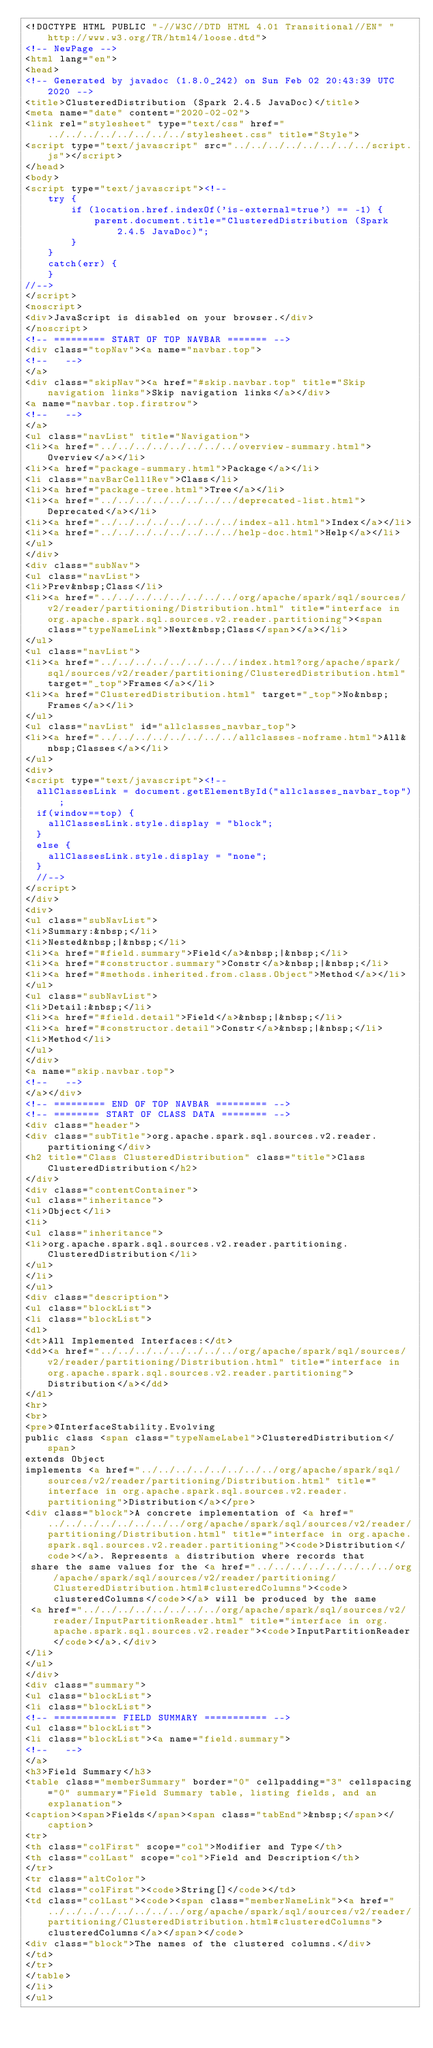<code> <loc_0><loc_0><loc_500><loc_500><_HTML_><!DOCTYPE HTML PUBLIC "-//W3C//DTD HTML 4.01 Transitional//EN" "http://www.w3.org/TR/html4/loose.dtd">
<!-- NewPage -->
<html lang="en">
<head>
<!-- Generated by javadoc (1.8.0_242) on Sun Feb 02 20:43:39 UTC 2020 -->
<title>ClusteredDistribution (Spark 2.4.5 JavaDoc)</title>
<meta name="date" content="2020-02-02">
<link rel="stylesheet" type="text/css" href="../../../../../../../../stylesheet.css" title="Style">
<script type="text/javascript" src="../../../../../../../../script.js"></script>
</head>
<body>
<script type="text/javascript"><!--
    try {
        if (location.href.indexOf('is-external=true') == -1) {
            parent.document.title="ClusteredDistribution (Spark 2.4.5 JavaDoc)";
        }
    }
    catch(err) {
    }
//-->
</script>
<noscript>
<div>JavaScript is disabled on your browser.</div>
</noscript>
<!-- ========= START OF TOP NAVBAR ======= -->
<div class="topNav"><a name="navbar.top">
<!--   -->
</a>
<div class="skipNav"><a href="#skip.navbar.top" title="Skip navigation links">Skip navigation links</a></div>
<a name="navbar.top.firstrow">
<!--   -->
</a>
<ul class="navList" title="Navigation">
<li><a href="../../../../../../../../overview-summary.html">Overview</a></li>
<li><a href="package-summary.html">Package</a></li>
<li class="navBarCell1Rev">Class</li>
<li><a href="package-tree.html">Tree</a></li>
<li><a href="../../../../../../../../deprecated-list.html">Deprecated</a></li>
<li><a href="../../../../../../../../index-all.html">Index</a></li>
<li><a href="../../../../../../../../help-doc.html">Help</a></li>
</ul>
</div>
<div class="subNav">
<ul class="navList">
<li>Prev&nbsp;Class</li>
<li><a href="../../../../../../../../org/apache/spark/sql/sources/v2/reader/partitioning/Distribution.html" title="interface in org.apache.spark.sql.sources.v2.reader.partitioning"><span class="typeNameLink">Next&nbsp;Class</span></a></li>
</ul>
<ul class="navList">
<li><a href="../../../../../../../../index.html?org/apache/spark/sql/sources/v2/reader/partitioning/ClusteredDistribution.html" target="_top">Frames</a></li>
<li><a href="ClusteredDistribution.html" target="_top">No&nbsp;Frames</a></li>
</ul>
<ul class="navList" id="allclasses_navbar_top">
<li><a href="../../../../../../../../allclasses-noframe.html">All&nbsp;Classes</a></li>
</ul>
<div>
<script type="text/javascript"><!--
  allClassesLink = document.getElementById("allclasses_navbar_top");
  if(window==top) {
    allClassesLink.style.display = "block";
  }
  else {
    allClassesLink.style.display = "none";
  }
  //-->
</script>
</div>
<div>
<ul class="subNavList">
<li>Summary:&nbsp;</li>
<li>Nested&nbsp;|&nbsp;</li>
<li><a href="#field.summary">Field</a>&nbsp;|&nbsp;</li>
<li><a href="#constructor.summary">Constr</a>&nbsp;|&nbsp;</li>
<li><a href="#methods.inherited.from.class.Object">Method</a></li>
</ul>
<ul class="subNavList">
<li>Detail:&nbsp;</li>
<li><a href="#field.detail">Field</a>&nbsp;|&nbsp;</li>
<li><a href="#constructor.detail">Constr</a>&nbsp;|&nbsp;</li>
<li>Method</li>
</ul>
</div>
<a name="skip.navbar.top">
<!--   -->
</a></div>
<!-- ========= END OF TOP NAVBAR ========= -->
<!-- ======== START OF CLASS DATA ======== -->
<div class="header">
<div class="subTitle">org.apache.spark.sql.sources.v2.reader.partitioning</div>
<h2 title="Class ClusteredDistribution" class="title">Class ClusteredDistribution</h2>
</div>
<div class="contentContainer">
<ul class="inheritance">
<li>Object</li>
<li>
<ul class="inheritance">
<li>org.apache.spark.sql.sources.v2.reader.partitioning.ClusteredDistribution</li>
</ul>
</li>
</ul>
<div class="description">
<ul class="blockList">
<li class="blockList">
<dl>
<dt>All Implemented Interfaces:</dt>
<dd><a href="../../../../../../../../org/apache/spark/sql/sources/v2/reader/partitioning/Distribution.html" title="interface in org.apache.spark.sql.sources.v2.reader.partitioning">Distribution</a></dd>
</dl>
<hr>
<br>
<pre>@InterfaceStability.Evolving
public class <span class="typeNameLabel">ClusteredDistribution</span>
extends Object
implements <a href="../../../../../../../../org/apache/spark/sql/sources/v2/reader/partitioning/Distribution.html" title="interface in org.apache.spark.sql.sources.v2.reader.partitioning">Distribution</a></pre>
<div class="block">A concrete implementation of <a href="../../../../../../../../org/apache/spark/sql/sources/v2/reader/partitioning/Distribution.html" title="interface in org.apache.spark.sql.sources.v2.reader.partitioning"><code>Distribution</code></a>. Represents a distribution where records that
 share the same values for the <a href="../../../../../../../../org/apache/spark/sql/sources/v2/reader/partitioning/ClusteredDistribution.html#clusteredColumns"><code>clusteredColumns</code></a> will be produced by the same
 <a href="../../../../../../../../org/apache/spark/sql/sources/v2/reader/InputPartitionReader.html" title="interface in org.apache.spark.sql.sources.v2.reader"><code>InputPartitionReader</code></a>.</div>
</li>
</ul>
</div>
<div class="summary">
<ul class="blockList">
<li class="blockList">
<!-- =========== FIELD SUMMARY =========== -->
<ul class="blockList">
<li class="blockList"><a name="field.summary">
<!--   -->
</a>
<h3>Field Summary</h3>
<table class="memberSummary" border="0" cellpadding="3" cellspacing="0" summary="Field Summary table, listing fields, and an explanation">
<caption><span>Fields</span><span class="tabEnd">&nbsp;</span></caption>
<tr>
<th class="colFirst" scope="col">Modifier and Type</th>
<th class="colLast" scope="col">Field and Description</th>
</tr>
<tr class="altColor">
<td class="colFirst"><code>String[]</code></td>
<td class="colLast"><code><span class="memberNameLink"><a href="../../../../../../../../org/apache/spark/sql/sources/v2/reader/partitioning/ClusteredDistribution.html#clusteredColumns">clusteredColumns</a></span></code>
<div class="block">The names of the clustered columns.</div>
</td>
</tr>
</table>
</li>
</ul></code> 